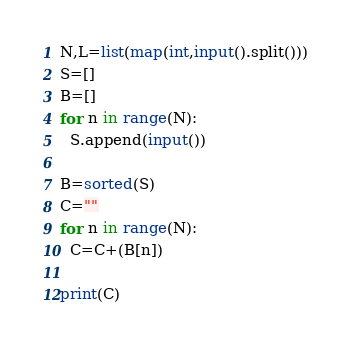Convert code to text. <code><loc_0><loc_0><loc_500><loc_500><_Python_>N,L=list(map(int,input().split()))
S=[]
B=[]
for n in range(N):
  S.append(input())
  
B=sorted(S)
C=""
for n in range(N):
  C=C+(B[n])
  
print(C)</code> 